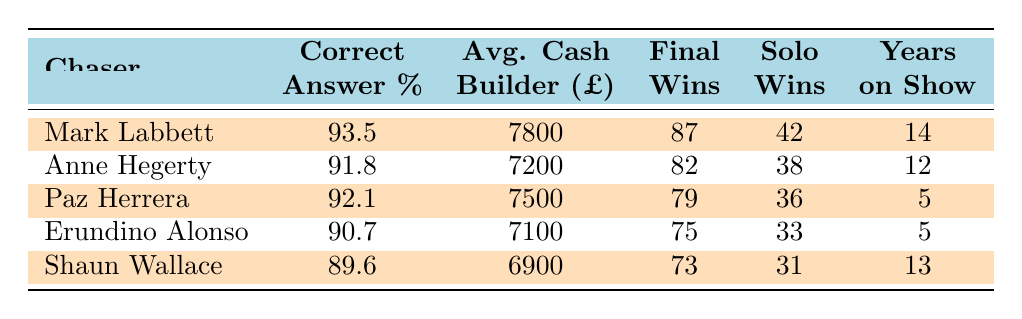What is the highest correct answer percentage among the chasers? By looking at the "Correct Answer %" column, Mark Labbett has the highest value at 93.5%, which is greater than the percentages of the other chasers.
Answer: 93.5% Who has the lowest average cash builder amount? The "Avg. Cash Builder" column shows that Shaun Wallace has the lowest value at 6900, compared to the other chasers listed.
Answer: 6900 What is the average number of years the chasers have been on their respective shows? To find the average, sum the years: 14 + 12 + 5 + 5 + 13 = 49, then divide by 5 (the number of chasers): 49/5 = 9.8 years.
Answer: 9.8 years Did any chaser win more than 80 final chases? Looking at the "Final Wins" column, both Mark Labbett (87) and Anne Hegerty (82) have more than 80 final chase wins, so the answer is yes.
Answer: Yes Which chaser has the most solo chases won? The "Solo Wins" column shows that Mark Labbett has the highest value at 42, which is greater than the other chasers' solo wins.
Answer: 42 Is there a chaser from "El Cazador" who has a correct answer percentage above 90%? In the "Correct Answer %" column, Paz Herrera (92.1) meets this criterion, indicating that yes, there is a chaser from "El Cazador" with a correct answer percentage above 90%.
Answer: Yes What is the difference in the average cash builder between Mark Labbett and Erundino Alonso? The average cash builder for Mark Labbett is 7800 and for Erundino Alonso, it is 7100. So, the difference is 7800 - 7100 = 700.
Answer: 700 How many solo chases has Anne Hegerty won in comparison to Paz Herrera? According to the "Solo Wins" column, Anne Hegerty has won 38 solo chases while Paz Herrera has won 36, resulting in Anne having 2 more wins than Paz.
Answer: 2 more Which show has a chaser with a correct answer percentage greater than 92%? Only Mark Labbett from "The Chase" has a correct answer percentage (93.5%) that is greater than 92%, indicating that the answer is yes.
Answer: Yes 